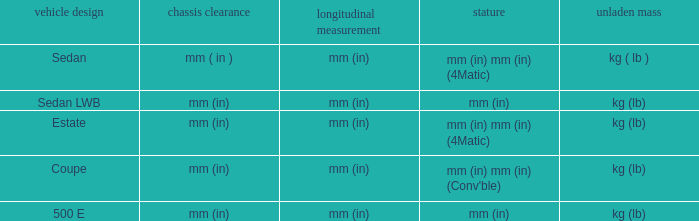What's the curb weight of the model with a wheelbase of mm (in) and height of mm (in) mm (in) (4Matic)? Kg ( lb ), kg (lb). 